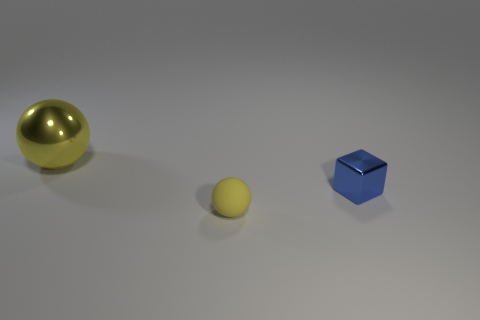Add 3 small metallic cubes. How many objects exist? 6 Subtract all spheres. How many objects are left? 1 Add 1 blue metal blocks. How many blue metal blocks are left? 2 Add 2 blue metallic blocks. How many blue metallic blocks exist? 3 Subtract 0 green balls. How many objects are left? 3 Subtract all yellow balls. Subtract all large brown cylinders. How many objects are left? 1 